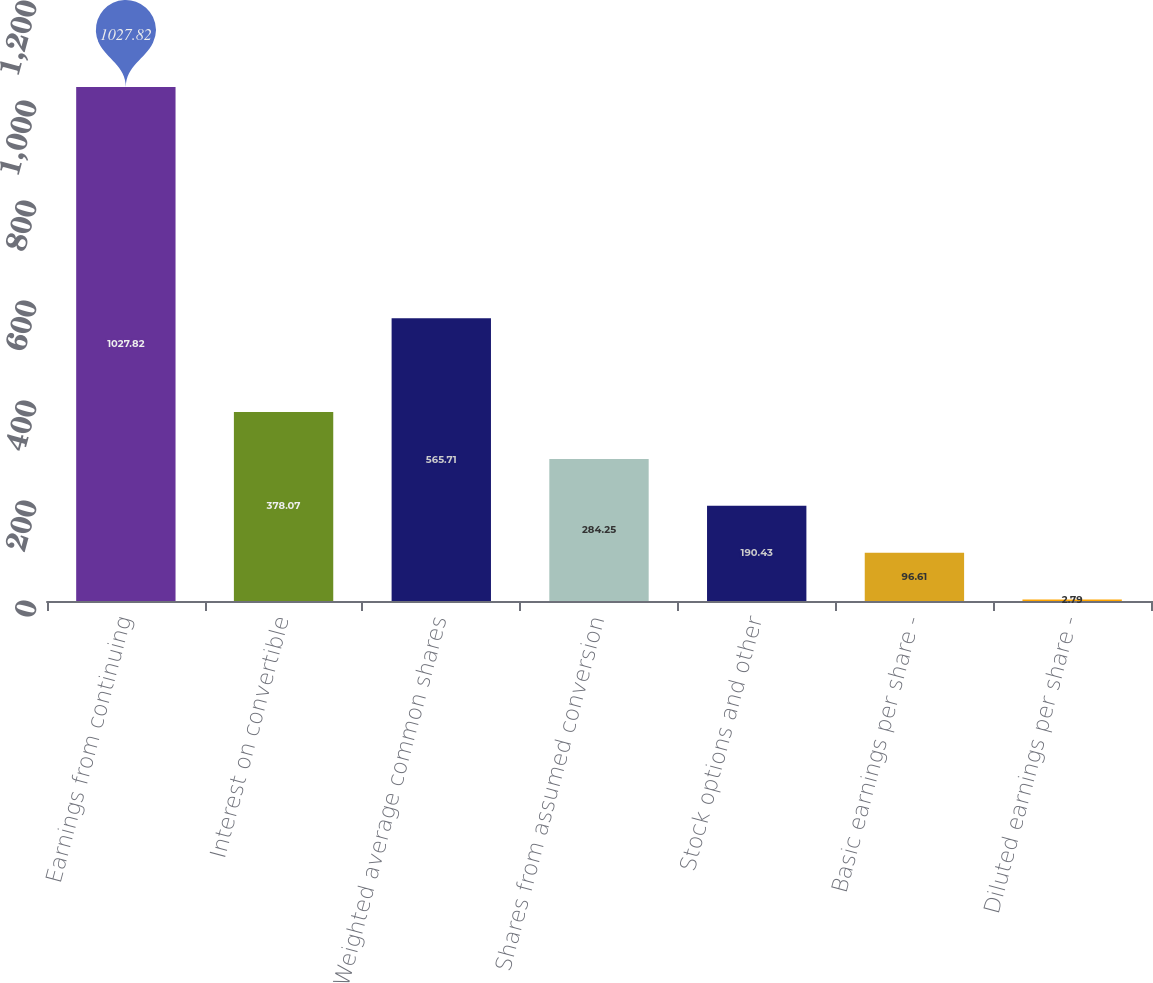Convert chart to OTSL. <chart><loc_0><loc_0><loc_500><loc_500><bar_chart><fcel>Earnings from continuing<fcel>Interest on convertible<fcel>Weighted average common shares<fcel>Shares from assumed conversion<fcel>Stock options and other<fcel>Basic earnings per share -<fcel>Diluted earnings per share -<nl><fcel>1027.82<fcel>378.07<fcel>565.71<fcel>284.25<fcel>190.43<fcel>96.61<fcel>2.79<nl></chart> 